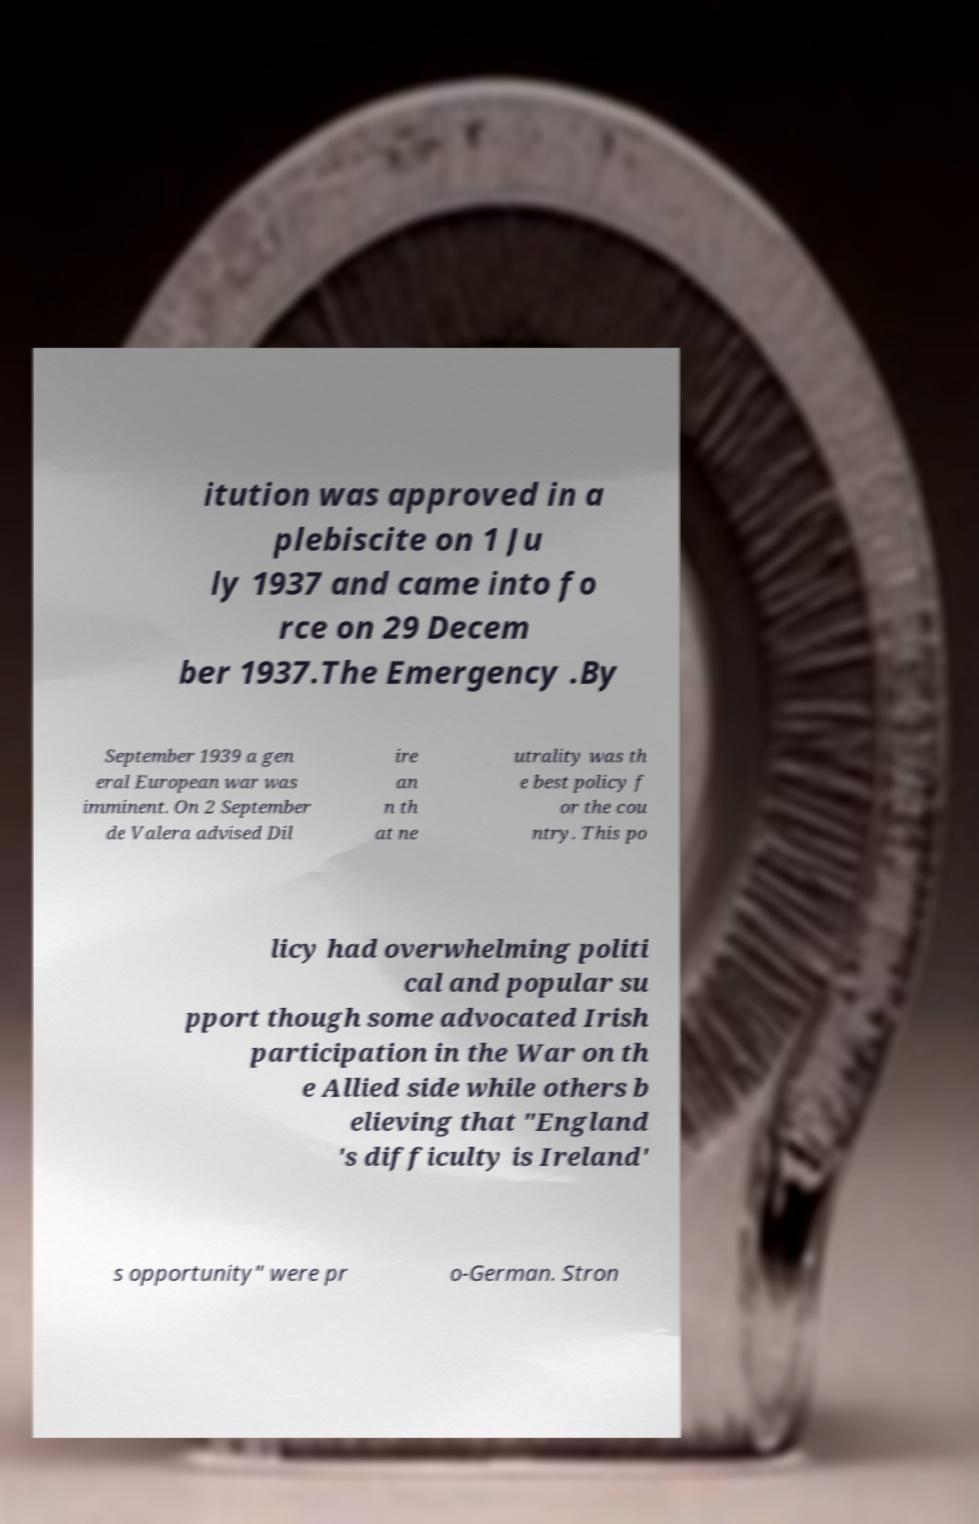Can you accurately transcribe the text from the provided image for me? itution was approved in a plebiscite on 1 Ju ly 1937 and came into fo rce on 29 Decem ber 1937.The Emergency .By September 1939 a gen eral European war was imminent. On 2 September de Valera advised Dil ire an n th at ne utrality was th e best policy f or the cou ntry. This po licy had overwhelming politi cal and popular su pport though some advocated Irish participation in the War on th e Allied side while others b elieving that "England 's difficulty is Ireland' s opportunity" were pr o-German. Stron 